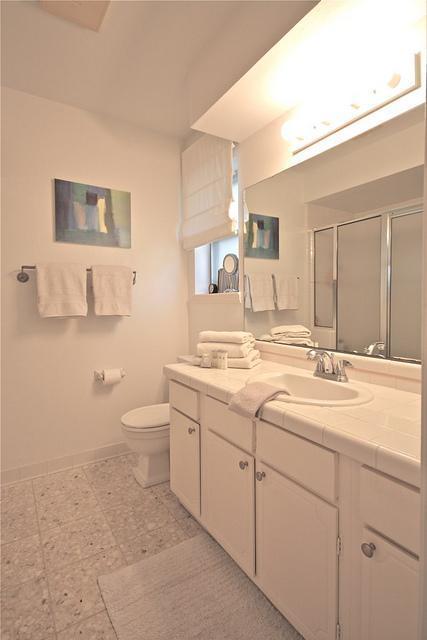How many people can go to the bathroom at once?
Give a very brief answer. 1. How many cabinets are in this room?
Give a very brief answer. 4. How many people can be seen?
Give a very brief answer. 0. 